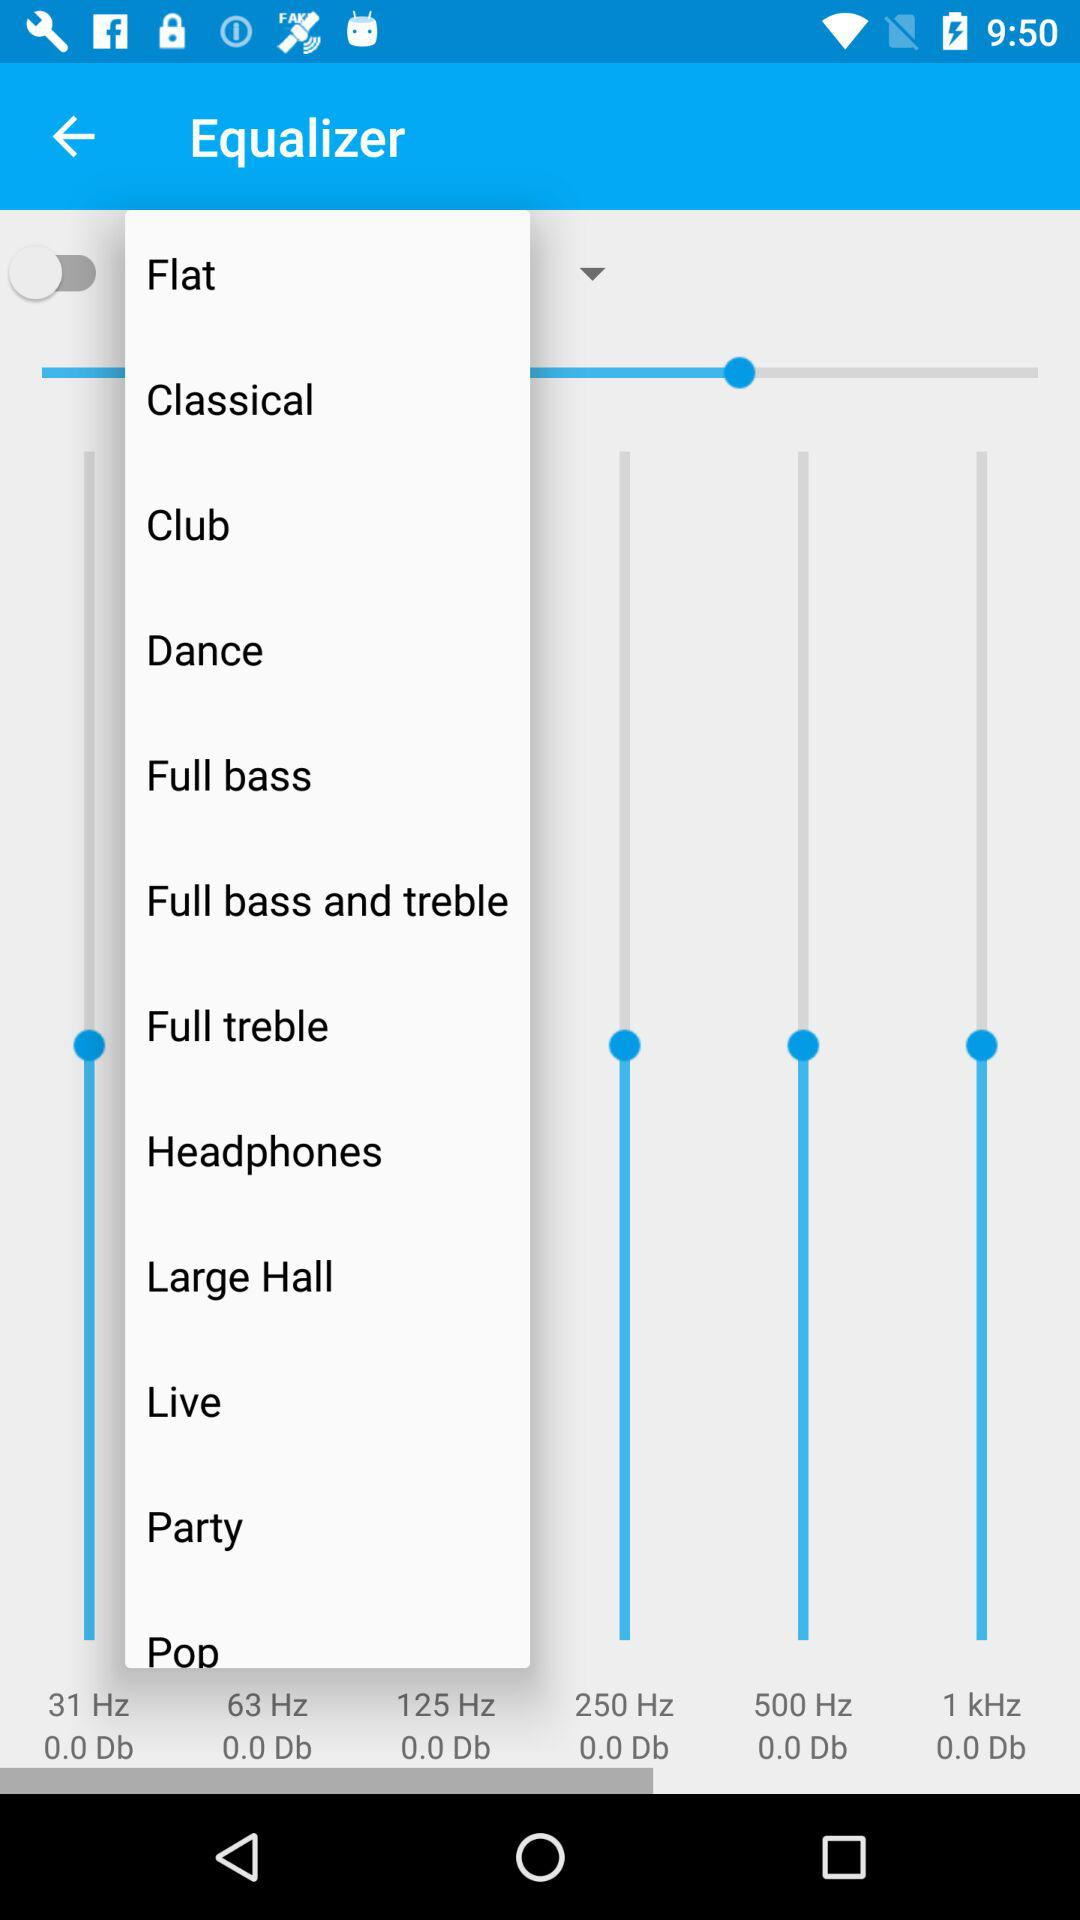Which equaliser category was chosen?
When the provided information is insufficient, respond with <no answer>. <no answer> 